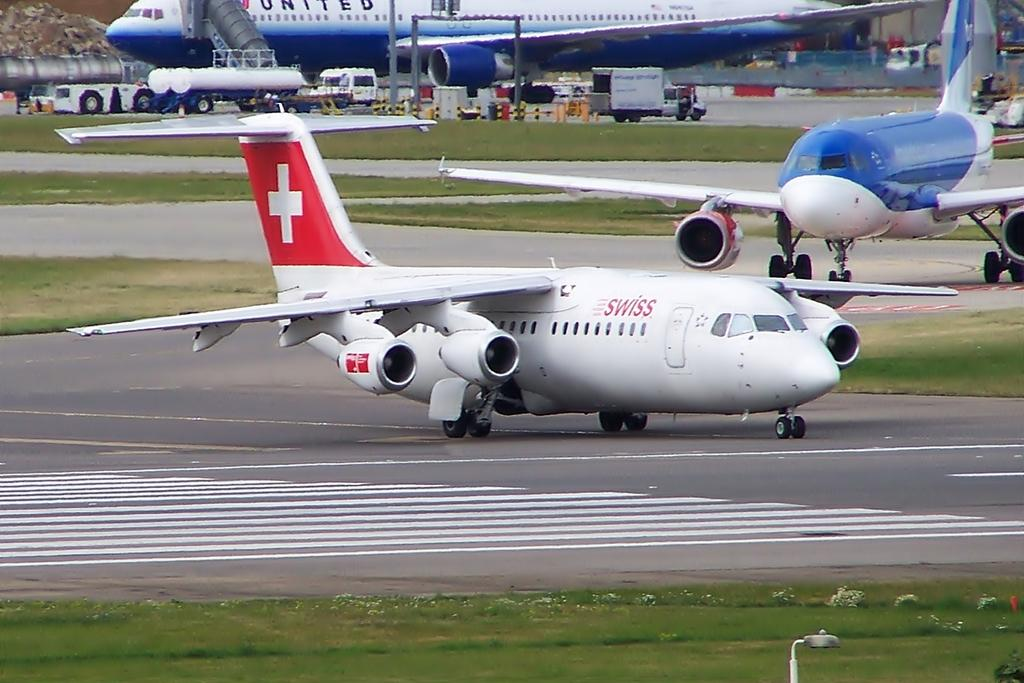What type of vehicles can be seen in the image? There are vehicles in the image. What is the landscape like around the aircrafts? There is grass around the aircrafts. What else is present in the image besides the aircrafts and vehicles? There are other objects present in the image. Where are the babies sleeping in the image? There are no babies or beds present in the image. 